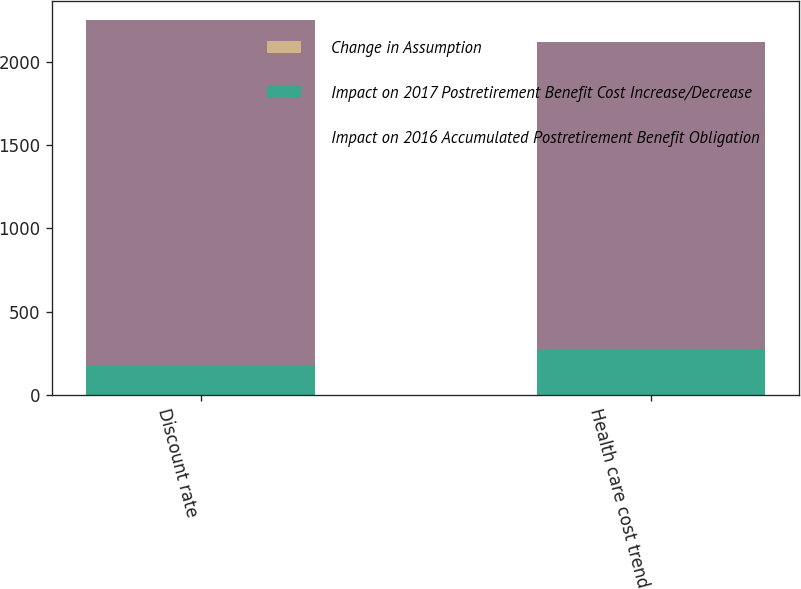Convert chart. <chart><loc_0><loc_0><loc_500><loc_500><stacked_bar_chart><ecel><fcel>Discount rate<fcel>Health care cost trend<nl><fcel>Change in Assumption<fcel>0.25<fcel>0.25<nl><fcel>Impact on 2017 Postretirement Benefit Cost Increase/Decrease<fcel>173<fcel>277<nl><fcel>Impact on 2016 Accumulated Postretirement Benefit Obligation<fcel>2082<fcel>1841<nl></chart> 